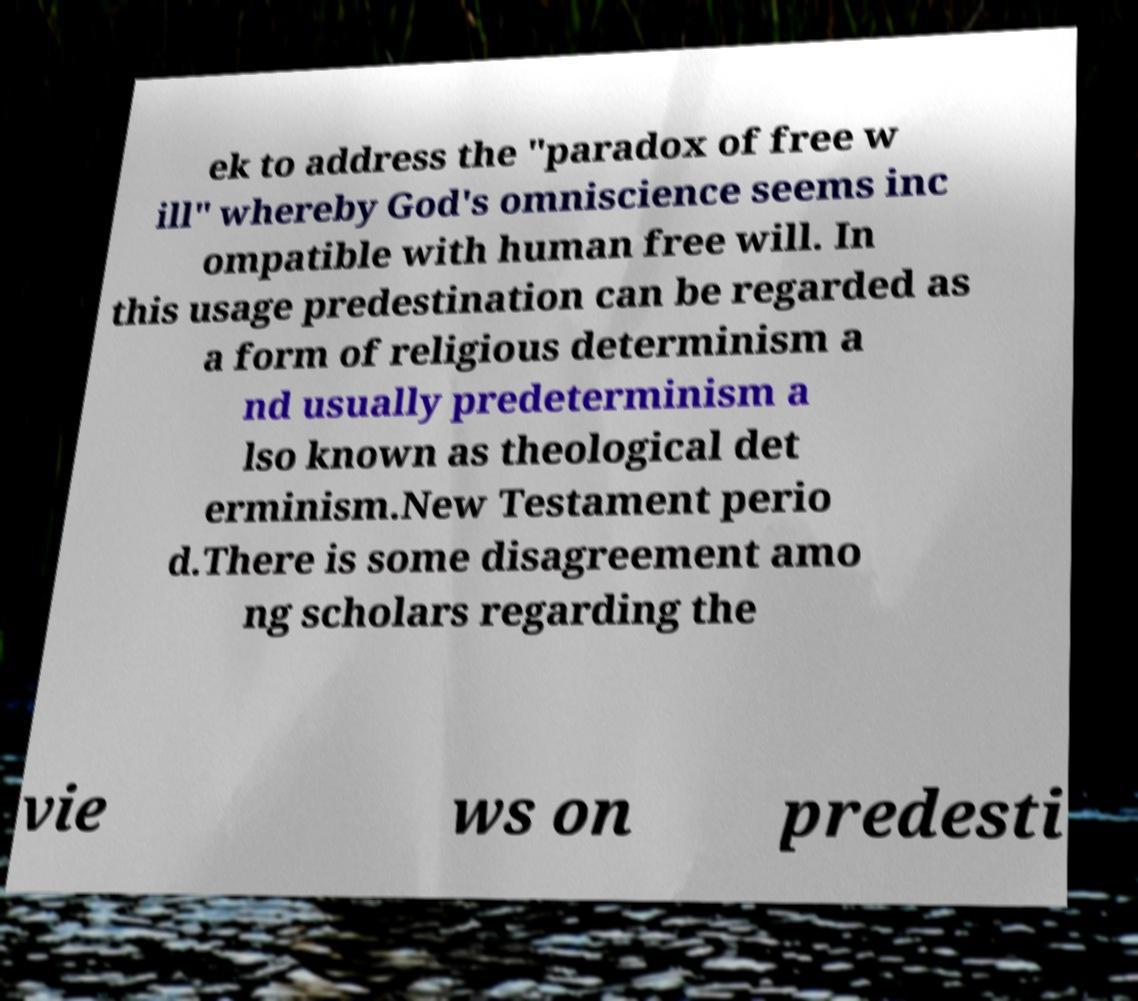Can you accurately transcribe the text from the provided image for me? ek to address the "paradox of free w ill" whereby God's omniscience seems inc ompatible with human free will. In this usage predestination can be regarded as a form of religious determinism a nd usually predeterminism a lso known as theological det erminism.New Testament perio d.There is some disagreement amo ng scholars regarding the vie ws on predesti 